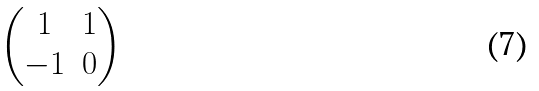Convert formula to latex. <formula><loc_0><loc_0><loc_500><loc_500>\begin{pmatrix} 1 & 1 \\ - 1 & 0 \end{pmatrix}</formula> 